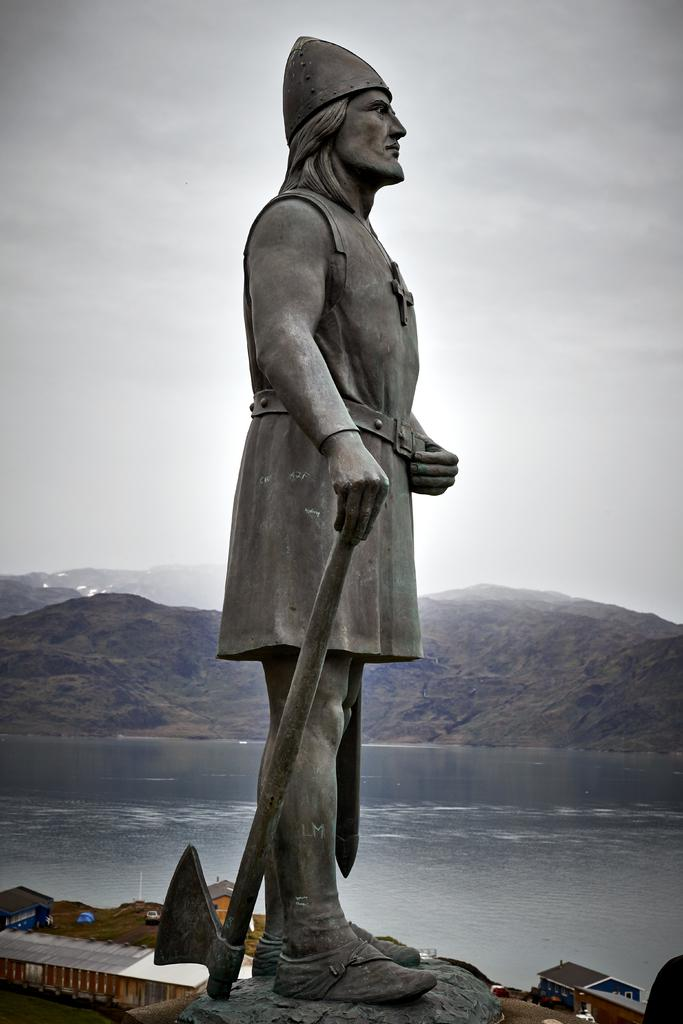What is the main subject in the image? There is a sculpture in the image. What can be seen in the background of the image? Water, mountains, and clouds are visible in the background of the image. Can you describe the shed in the image? There is a shed at the bottom left of the image. What type of rod is the sculpture holding in the image? There is no rod present in the image; the sculpture does not hold any object. 